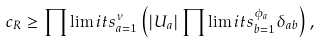Convert formula to latex. <formula><loc_0><loc_0><loc_500><loc_500>c _ { R } \geq \prod \lim i t s ^ { \nu } _ { a = 1 } \left ( | U _ { a } | \prod \lim i t s ^ { \phi _ { a } } _ { b = 1 } \delta _ { a b } \right ) ,</formula> 